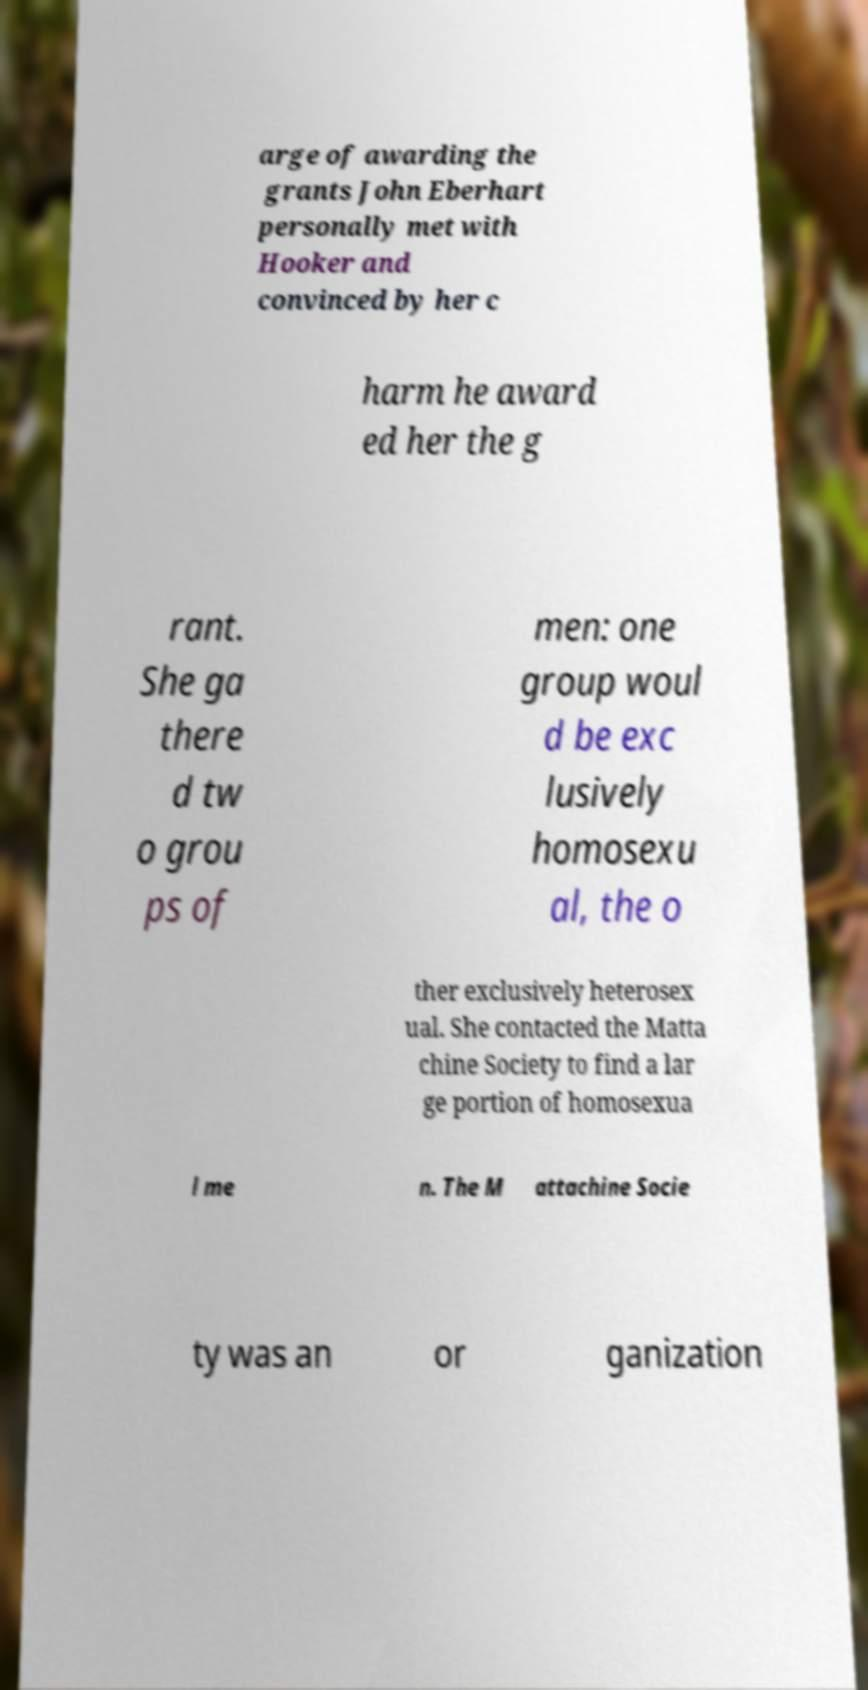Could you extract and type out the text from this image? arge of awarding the grants John Eberhart personally met with Hooker and convinced by her c harm he award ed her the g rant. She ga there d tw o grou ps of men: one group woul d be exc lusively homosexu al, the o ther exclusively heterosex ual. She contacted the Matta chine Society to find a lar ge portion of homosexua l me n. The M attachine Socie ty was an or ganization 